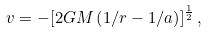<formula> <loc_0><loc_0><loc_500><loc_500>v = - [ 2 G M \left ( 1 / r - 1 / a \right ) ] ^ { \frac { 1 } { 2 } } \, ,</formula> 